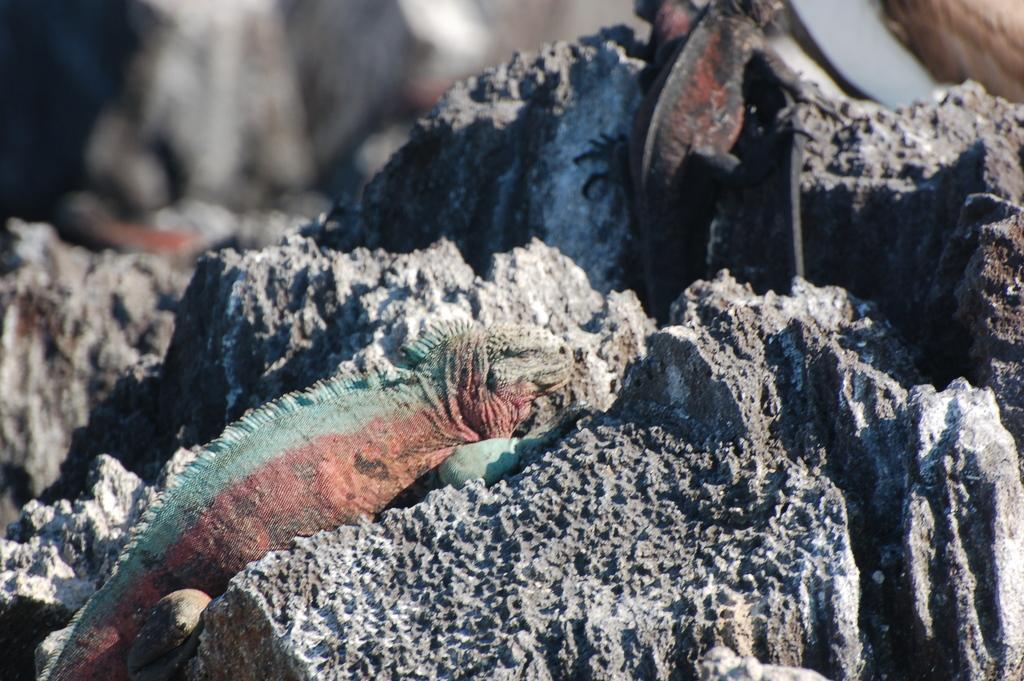What type of animals are in the image? There are chameleons in the image. Where are the chameleons located? The chameleons are on a rock. What type of mailbox can be seen near the office in the image? There is no mailbox or office present in the image; it features chameleons on a rock. 